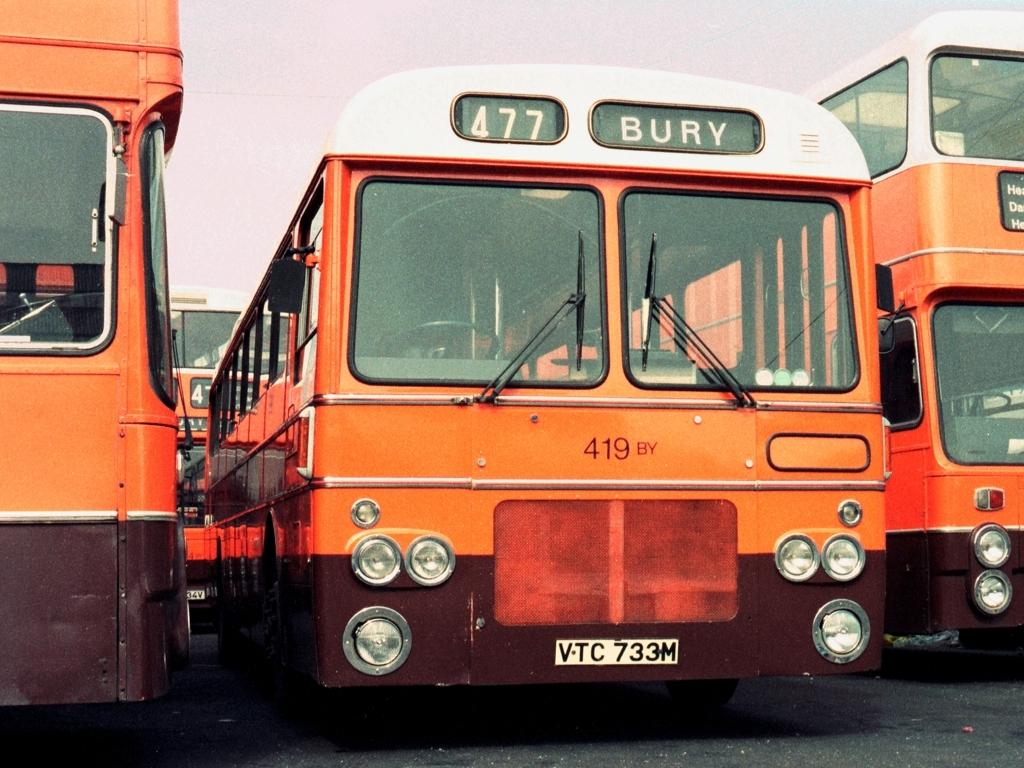Are there any quality issues with this image? The image appears to suffer from a slight color imbalance, with the reds being more saturated, which might be indicative of the aging of the photograph or the way it was developed. There may also be minor artifacts and graininess due to the resolution and age of the photograph. 